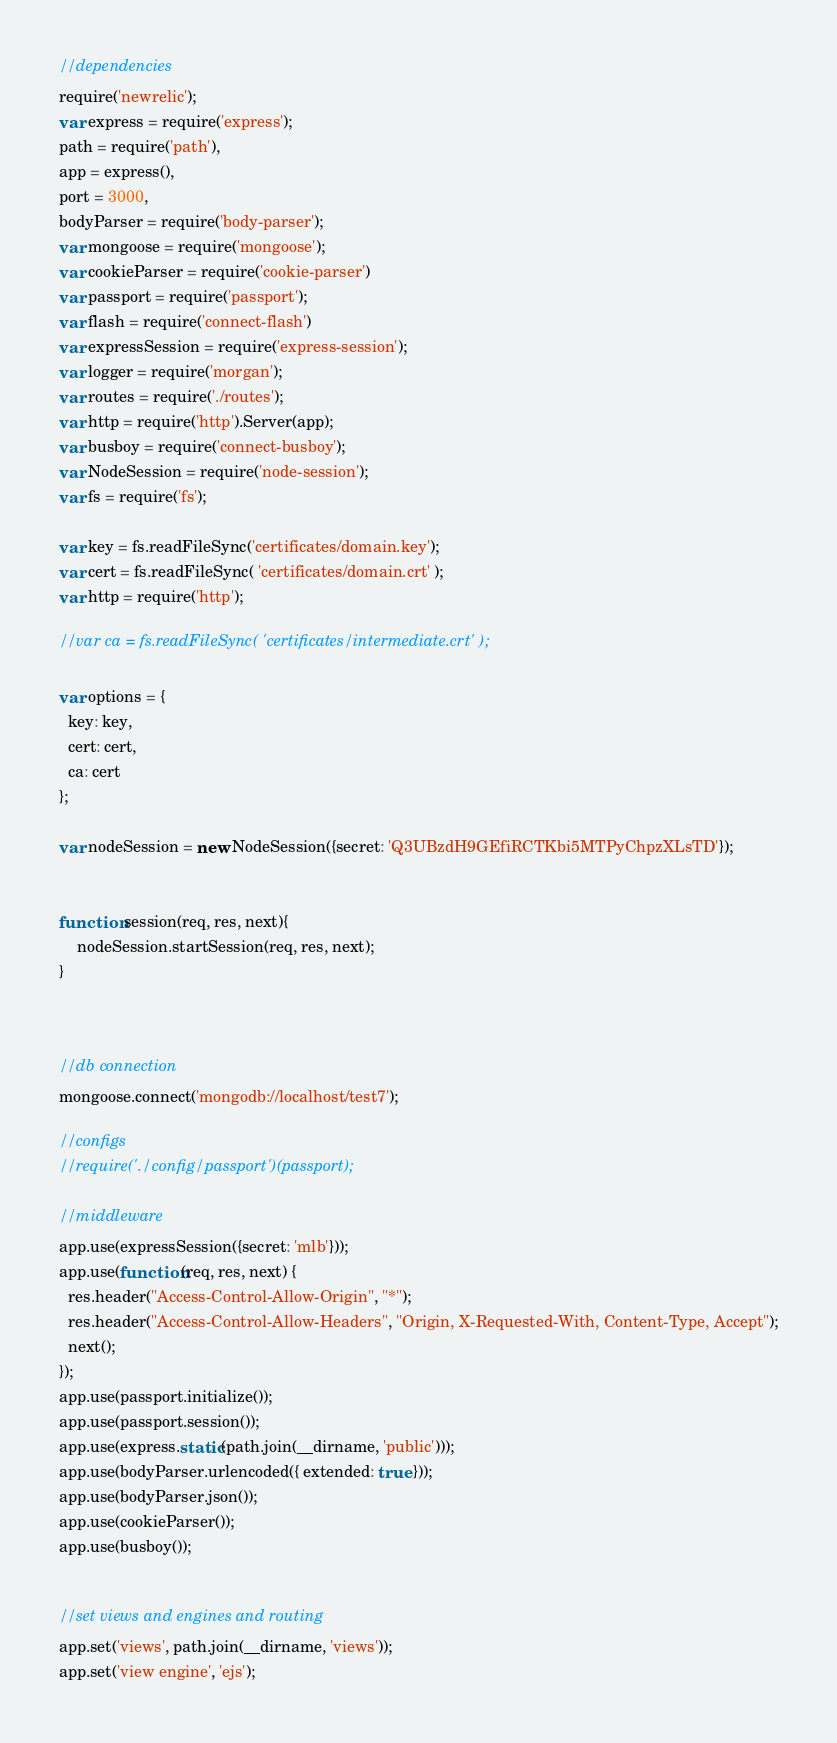Convert code to text. <code><loc_0><loc_0><loc_500><loc_500><_JavaScript_>//dependencies
require('newrelic');
var express = require('express');
path = require('path'),
app = express(),
port = 3000,
bodyParser = require('body-parser');
var mongoose = require('mongoose');
var cookieParser = require('cookie-parser')
var passport = require('passport');
var flash = require('connect-flash')
var expressSession = require('express-session');
var logger = require('morgan');
var routes = require('./routes');
var http = require('http').Server(app);
var busboy = require('connect-busboy');
var NodeSession = require('node-session');
var fs = require('fs');

var key = fs.readFileSync('certificates/domain.key');
var cert = fs.readFileSync( 'certificates/domain.crt' );
var http = require('http');

//var ca = fs.readFileSync( 'certificates/intermediate.crt' );

var options = {
  key: key,
  cert: cert,
  ca: cert
};

var nodeSession = new NodeSession({secret: 'Q3UBzdH9GEfiRCTKbi5MTPyChpzXLsTD'});


function session(req, res, next){
    nodeSession.startSession(req, res, next);
}



//db connection
mongoose.connect('mongodb://localhost/test7');

//configs
//require('./config/passport')(passport);

//middleware
app.use(expressSession({secret: 'mlb'}));
app.use(function(req, res, next) {
  res.header("Access-Control-Allow-Origin", "*");
  res.header("Access-Control-Allow-Headers", "Origin, X-Requested-With, Content-Type, Accept");
  next();
});
app.use(passport.initialize());
app.use(passport.session());
app.use(express.static(path.join(__dirname, 'public')));
app.use(bodyParser.urlencoded({ extended: true }));
app.use(bodyParser.json());
app.use(cookieParser());
app.use(busboy());


//set views and engines and routing
app.set('views', path.join(__dirname, 'views'));
app.set('view engine', 'ejs');</code> 